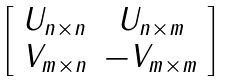<formula> <loc_0><loc_0><loc_500><loc_500>\left [ \begin{array} { c c } U _ { n \times n } & U _ { n \times m } \\ V _ { m \times n } & - V _ { m \times m } \end{array} \right ]</formula> 